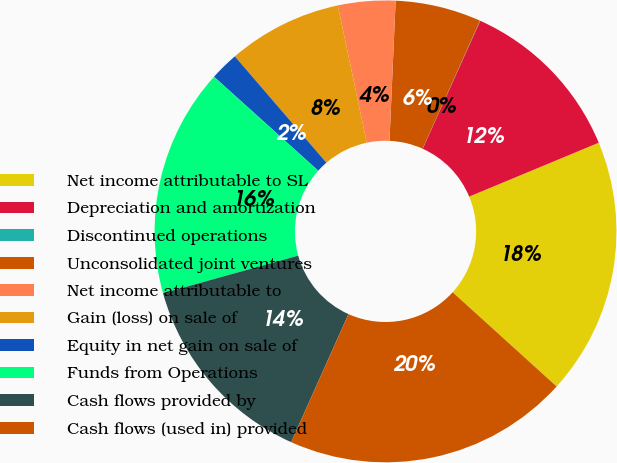<chart> <loc_0><loc_0><loc_500><loc_500><pie_chart><fcel>Net income attributable to SL<fcel>Depreciation and amortization<fcel>Discontinued operations<fcel>Unconsolidated joint ventures<fcel>Net income attributable to<fcel>Gain (loss) on sale of<fcel>Equity in net gain on sale of<fcel>Funds from Operations<fcel>Cash flows provided by<fcel>Cash flows (used in) provided<nl><fcel>17.99%<fcel>12.0%<fcel>0.02%<fcel>6.01%<fcel>4.01%<fcel>8.0%<fcel>2.01%<fcel>15.99%<fcel>13.99%<fcel>19.98%<nl></chart> 